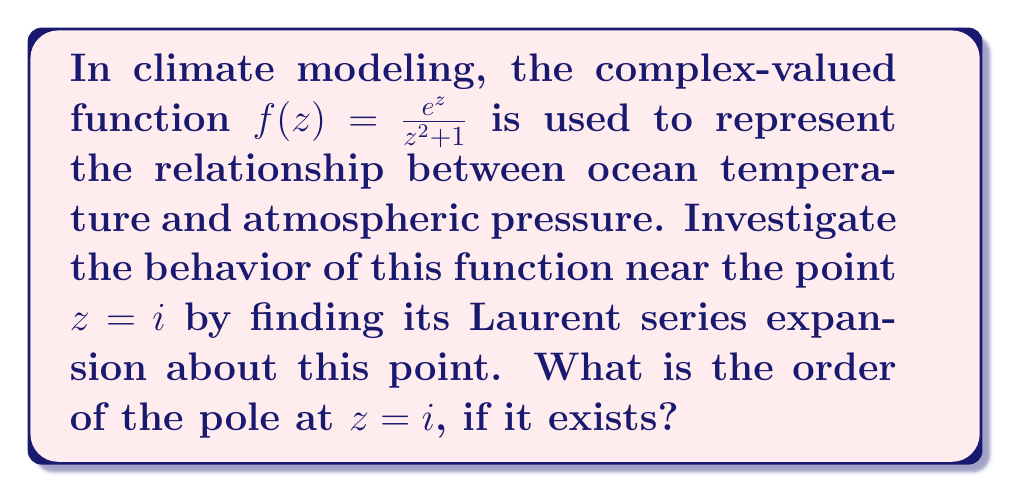Give your solution to this math problem. To investigate the behavior of $f(z) = \frac{e^z}{z^2 + 1}$ near $z = i$, we need to find its Laurent series expansion about this point. Let's approach this step-by-step:

1) First, we notice that $z^2 + 1 = (z+i)(z-i)$, so $z = i$ is indeed a pole of the function.

2) To find the Laurent series, we need to separate the function into a part that's analytic at $z = i$ and a part with negative powers of $(z-i)$:

   $f(z) = \frac{e^z}{(z+i)(z-i)}$

3) We can use partial fraction decomposition:

   $\frac{1}{(z+i)(z-i)} = \frac{A}{z-i} + \frac{B}{z+i}$

   where $A$ and $B$ are constants to be determined.

4) Solving for $A$ and $B$:

   $1 = A(z+i) + B(z-i)$
   
   When $z = i$: $1 = A(2i)$, so $A = -\frac{i}{2}$
   
   When $z = -i$: $1 = B(-2i)$, so $B = \frac{i}{2}$

5) Therefore:

   $f(z) = e^z(\frac{-i/2}{z-i} + \frac{i/2}{z+i})$

6) Now, we focus on the term $\frac{e^z}{z-i}$ as we're interested in the behavior near $z = i$:

   $\frac{e^z}{z-i} = \frac{e^i}{z-i} \cdot \frac{e^{z-i}}{e^i} = \frac{e^i}{z-i} \cdot e^{z-i}$

7) We know the Taylor series for $e^w$:

   $e^w = 1 + w + \frac{w^2}{2!} + \frac{w^3}{3!} + ...$

8) Substituting $w = z-i$:

   $e^{z-i} = 1 + (z-i) + \frac{(z-i)^2}{2!} + \frac{(z-i)^3}{3!} + ...$

9) Therefore, the Laurent series of $f(z)$ about $z = i$ is:

   $f(z) = \frac{-ie^i/2}{z-i}(1 + (z-i) + \frac{(z-i)^2}{2!} + ...) + \frac{ie^z}{2(z+i)}$

10) The term $\frac{ie^z}{2(z+i)}$ is analytic at $z = i$, so it doesn't contribute to the negative powers in the Laurent series.

11) From this expansion, we can see that there is only one term with a negative power of $(z-i)$, and its power is -1.

Therefore, $z = i$ is a simple pole (order 1) of the function $f(z)$.
Answer: The order of the pole at $z = i$ is 1 (a simple pole). 